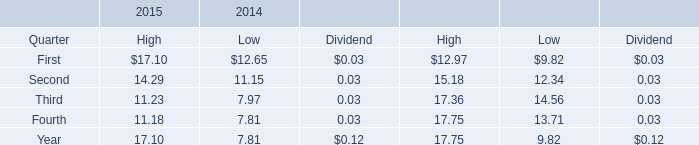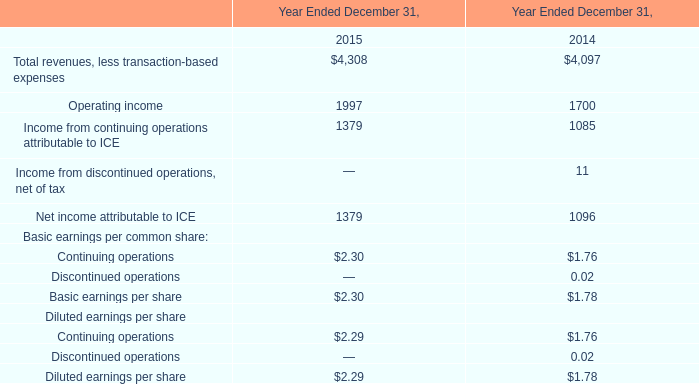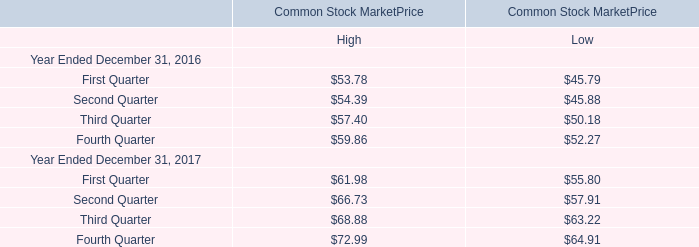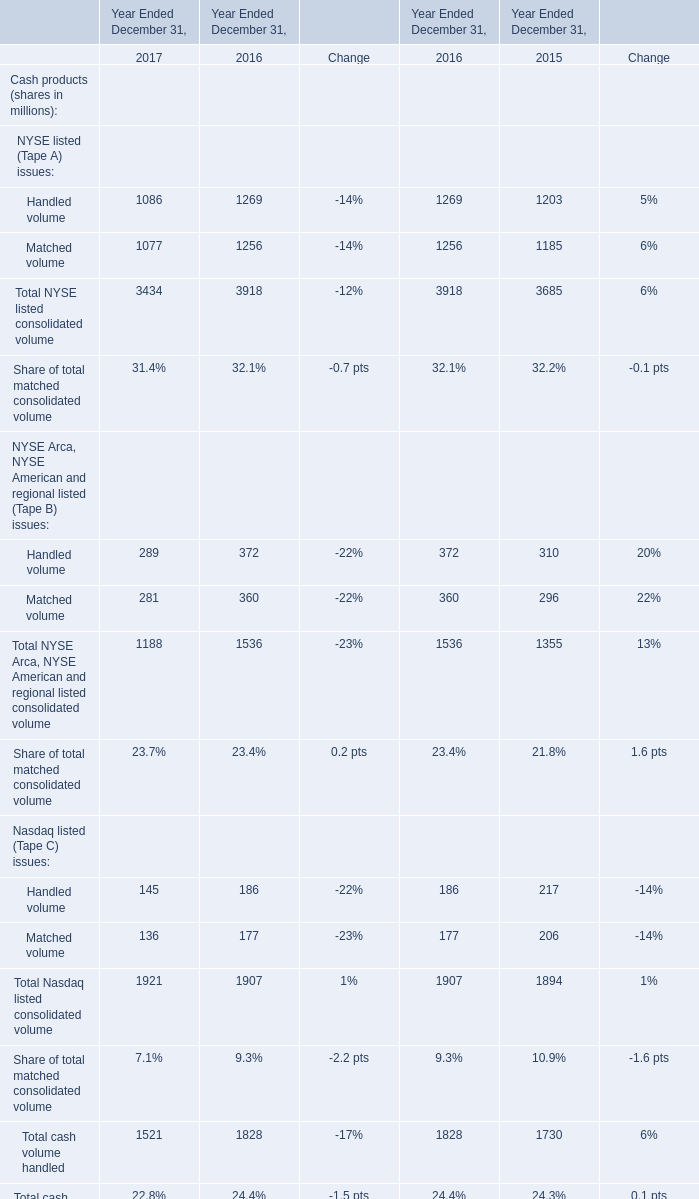In the year with the most First Quarter of High in Table 2, what is the growth rate of Total NYSE listed consolidated volume in Table 3? 
Computations: ((3434 - 3918) / 3918)
Answer: -0.12353. 